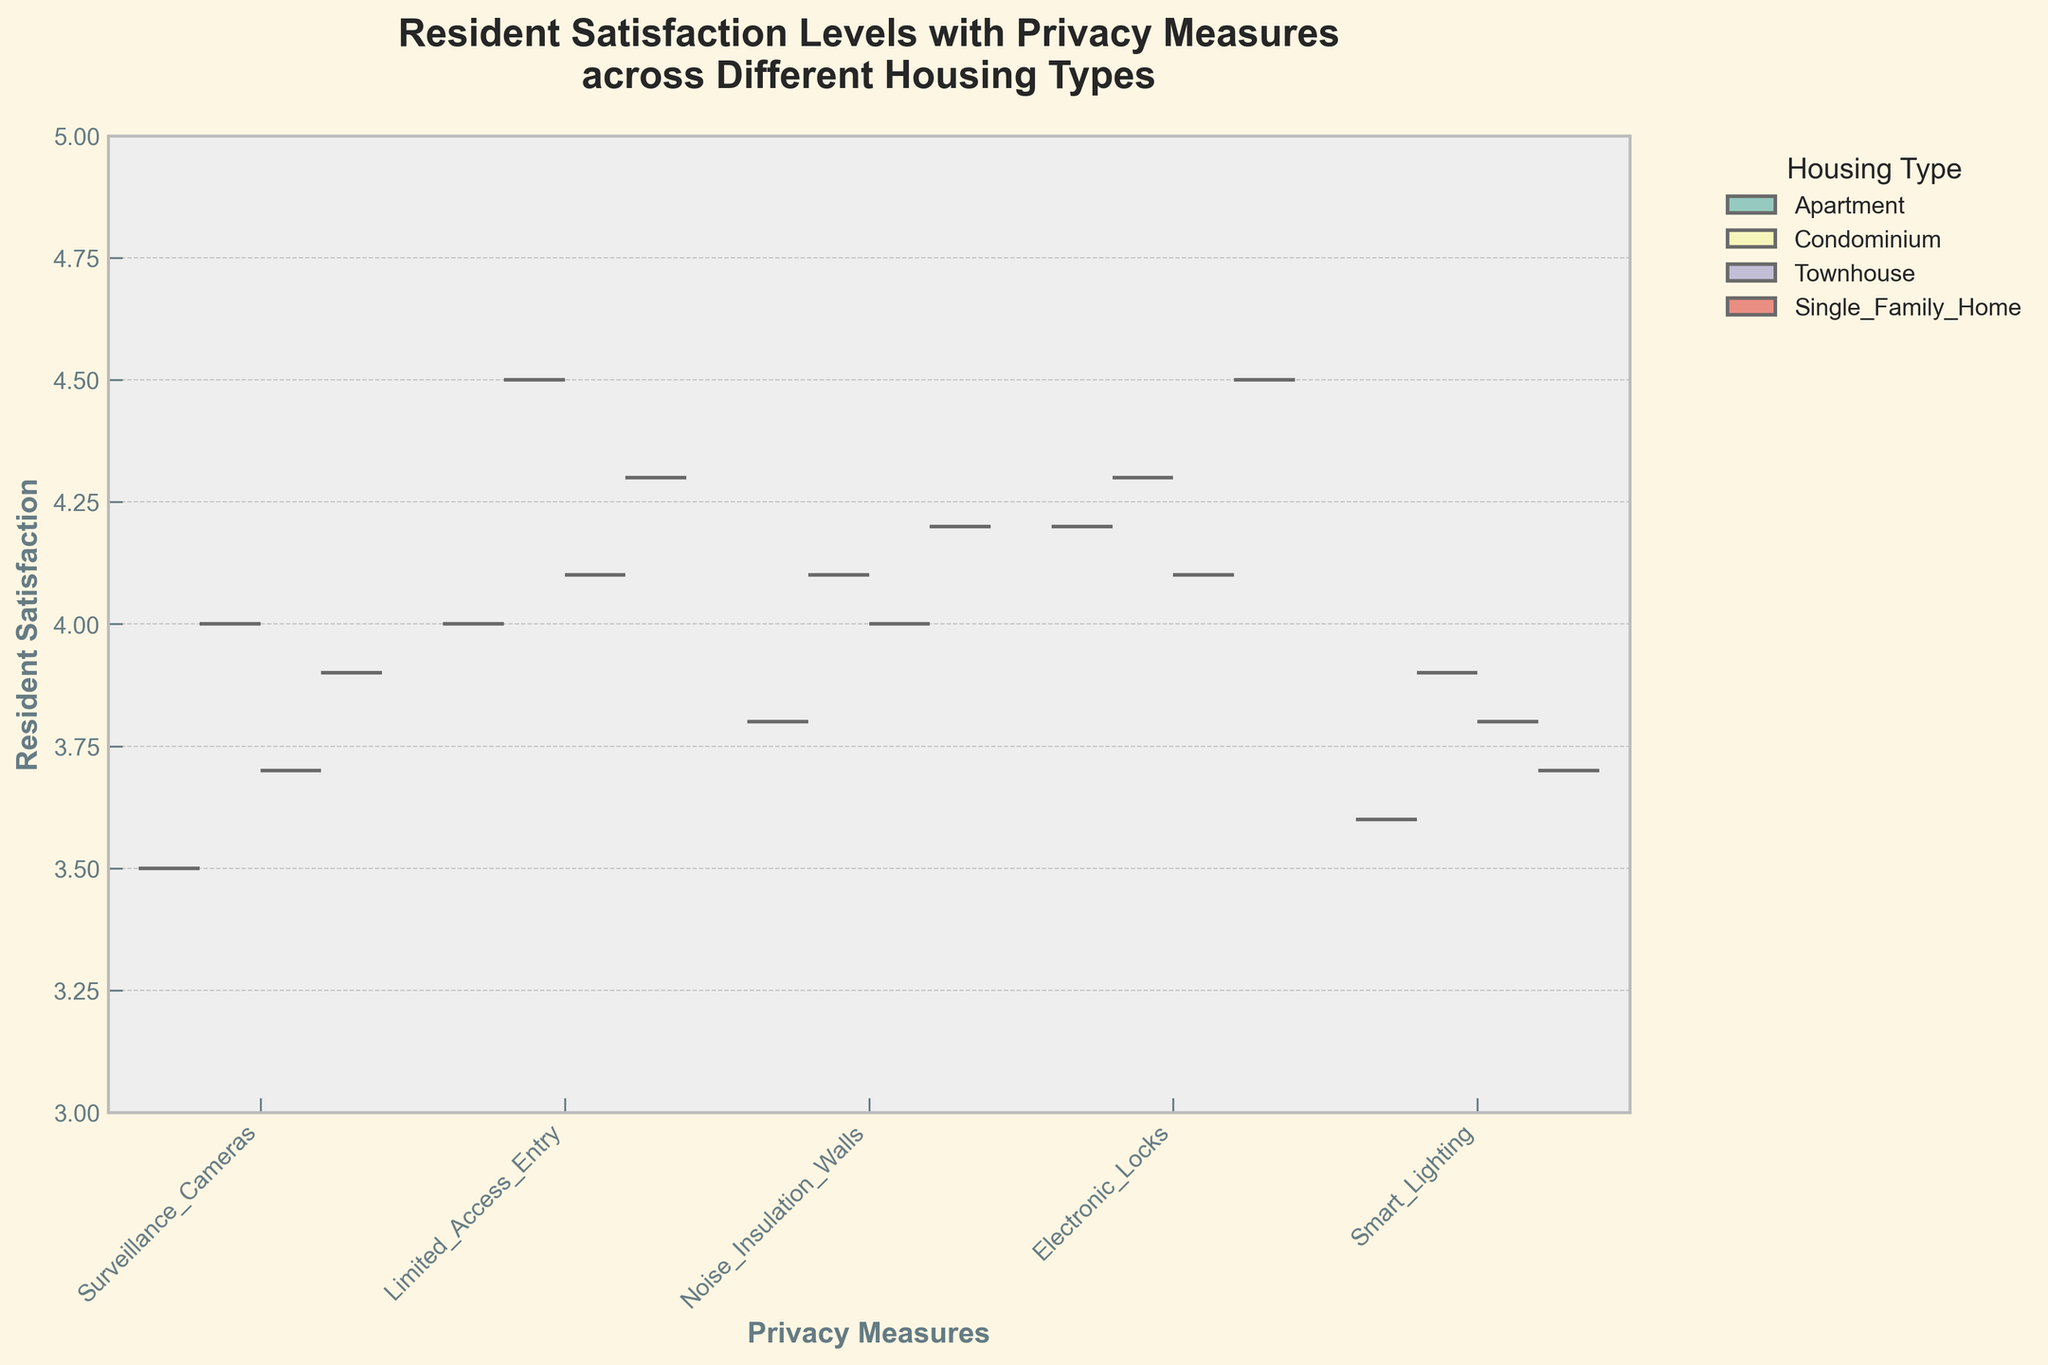What is the title of the plot? The title of the plot is located at the top and is usually the most prominent text. In this case, it states, "Resident Satisfaction Levels with Privacy Measures across Different Housing Types."
Answer: Resident Satisfaction Levels with Privacy Measures across Different Housing Types What range does the y-axis cover? By looking at the y-axis, we can see the minimum and maximum values it spans. The y-axis starts at 3 and goes up to 5.
Answer: 3 to 5 Which privacy measure has the highest resident satisfaction in Single Family Home? We need to identify which privacy measure has the highest violin plot peak for Single Family Home. Here, it's the Electronic Locks with a peak near the top of the y-axis, around 4.5.
Answer: Electronic Locks How do resident satisfaction levels for Surveillance Cameras compare between Apartments and Condominiums? By comparing the halves of the violin plots for Surveillance Cameras, we notice that Condominiums have a slightly higher resident satisfaction level than Apartments. The Condominiums' peak is closer to 4.0, while Apartments are around 3.5.
Answer: Condominiums > Apartments Which housing type has the narrowest range of resident satisfaction for Noise Insulation Walls? We determine the range by looking at the spread of the violin plots. The Condominium's violin plot for Noise Insulation Walls is less spread out compared to others, indicating a narrower range.
Answer: Condominium Are resident satisfaction levels for Smart Lighting higher in Apartments or Townhouses? By comparing the violin halves, we see that the resident satisfaction level for Smart Lighting is slightly higher in Townhouses. Townhouse peaks at about 3.8, while Apartments slightly lower around 3.6.
Answer: Townhouses Which privacy measure shows the most significant difference in satisfaction levels between different housing types? We look at the width and overlap of the violin plots. Surveillance Cameras display the most significant variation across housing types, evident by the considerable difference in the peaks and widths of the violins.
Answer: Surveillance Cameras What is the median satisfaction level for Limited Access Entry in Condominiums? The median is typically marked by a line within the violin plots. For Limited Access Entry in Condominiums, the median line is at 4.5.
Answer: 4.5 